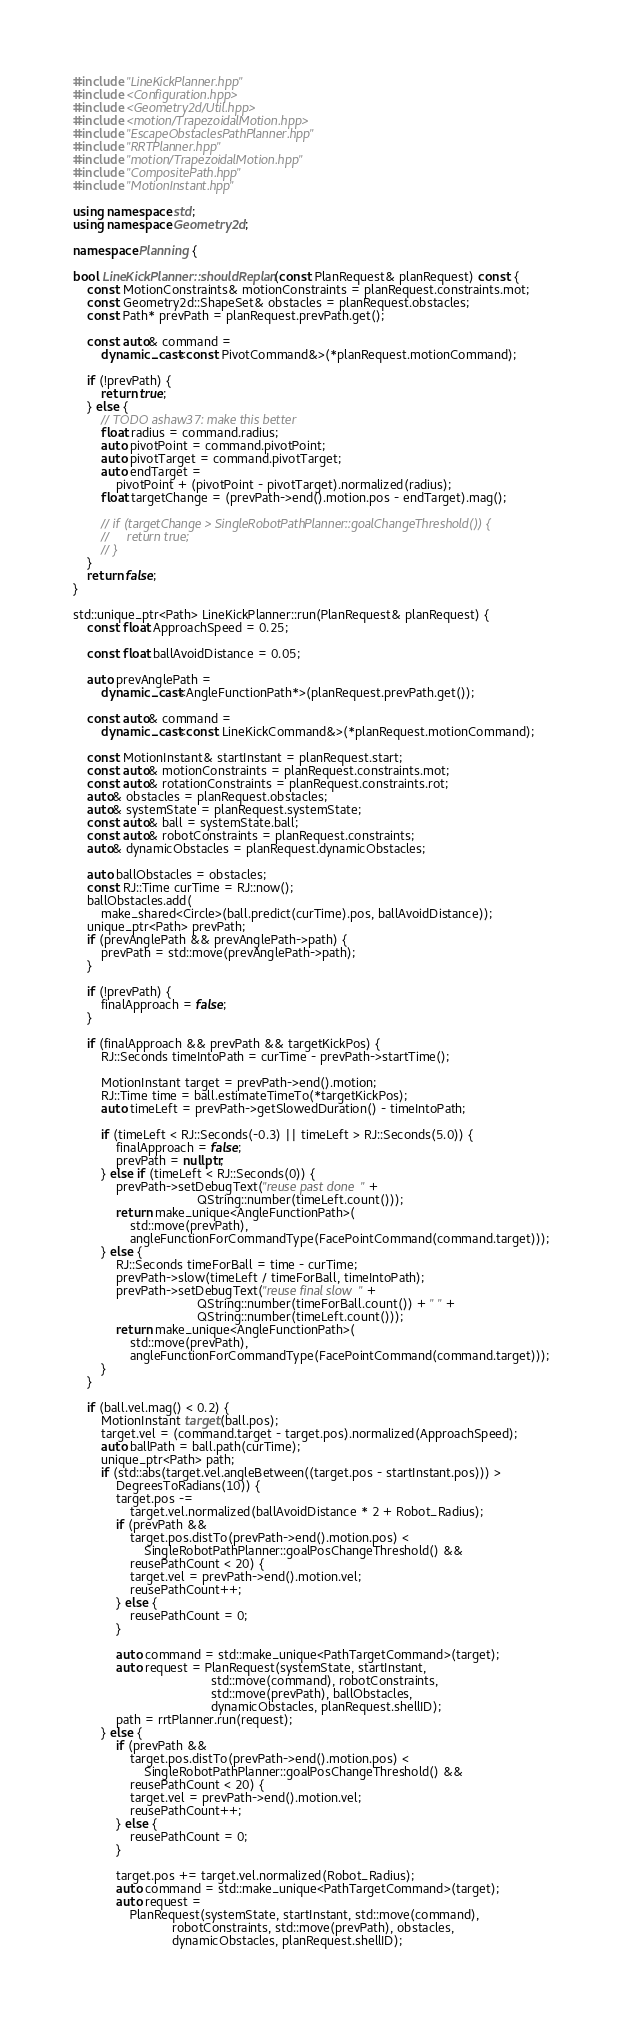<code> <loc_0><loc_0><loc_500><loc_500><_C++_>#include "LineKickPlanner.hpp"
#include <Configuration.hpp>
#include <Geometry2d/Util.hpp>
#include <motion/TrapezoidalMotion.hpp>
#include "EscapeObstaclesPathPlanner.hpp"
#include "RRTPlanner.hpp"
#include "motion/TrapezoidalMotion.hpp"
#include "CompositePath.hpp"
#include "MotionInstant.hpp"

using namespace std;
using namespace Geometry2d;

namespace Planning {

bool LineKickPlanner::shouldReplan(const PlanRequest& planRequest) const {
    const MotionConstraints& motionConstraints = planRequest.constraints.mot;
    const Geometry2d::ShapeSet& obstacles = planRequest.obstacles;
    const Path* prevPath = planRequest.prevPath.get();

    const auto& command =
        dynamic_cast<const PivotCommand&>(*planRequest.motionCommand);

    if (!prevPath) {
        return true;
    } else {
        // TODO ashaw37: make this better
        float radius = command.radius;
        auto pivotPoint = command.pivotPoint;
        auto pivotTarget = command.pivotTarget;
        auto endTarget =
            pivotPoint + (pivotPoint - pivotTarget).normalized(radius);
        float targetChange = (prevPath->end().motion.pos - endTarget).mag();

        // if (targetChange > SingleRobotPathPlanner::goalChangeThreshold()) {
        //     return true;
        // }
    }
    return false;
}

std::unique_ptr<Path> LineKickPlanner::run(PlanRequest& planRequest) {
    const float ApproachSpeed = 0.25;

    const float ballAvoidDistance = 0.05;

    auto prevAnglePath =
        dynamic_cast<AngleFunctionPath*>(planRequest.prevPath.get());

    const auto& command =
        dynamic_cast<const LineKickCommand&>(*planRequest.motionCommand);

    const MotionInstant& startInstant = planRequest.start;
    const auto& motionConstraints = planRequest.constraints.mot;
    const auto& rotationConstraints = planRequest.constraints.rot;
    auto& obstacles = planRequest.obstacles;
    auto& systemState = planRequest.systemState;
    const auto& ball = systemState.ball;
    const auto& robotConstraints = planRequest.constraints;
    auto& dynamicObstacles = planRequest.dynamicObstacles;

    auto ballObstacles = obstacles;
    const RJ::Time curTime = RJ::now();
    ballObstacles.add(
        make_shared<Circle>(ball.predict(curTime).pos, ballAvoidDistance));
    unique_ptr<Path> prevPath;
    if (prevAnglePath && prevAnglePath->path) {
        prevPath = std::move(prevAnglePath->path);
    }

    if (!prevPath) {
        finalApproach = false;
    }

    if (finalApproach && prevPath && targetKickPos) {
        RJ::Seconds timeIntoPath = curTime - prevPath->startTime();

        MotionInstant target = prevPath->end().motion;
        RJ::Time time = ball.estimateTimeTo(*targetKickPos);
        auto timeLeft = prevPath->getSlowedDuration() - timeIntoPath;

        if (timeLeft < RJ::Seconds(-0.3) || timeLeft > RJ::Seconds(5.0)) {
            finalApproach = false;
            prevPath = nullptr;
        } else if (timeLeft < RJ::Seconds(0)) {
            prevPath->setDebugText("reuse past done " +
                                   QString::number(timeLeft.count()));
            return make_unique<AngleFunctionPath>(
                std::move(prevPath),
                angleFunctionForCommandType(FacePointCommand(command.target)));
        } else {
            RJ::Seconds timeForBall = time - curTime;
            prevPath->slow(timeLeft / timeForBall, timeIntoPath);
            prevPath->setDebugText("reuse final slow " +
                                   QString::number(timeForBall.count()) + " " +
                                   QString::number(timeLeft.count()));
            return make_unique<AngleFunctionPath>(
                std::move(prevPath),
                angleFunctionForCommandType(FacePointCommand(command.target)));
        }
    }

    if (ball.vel.mag() < 0.2) {
        MotionInstant target(ball.pos);
        target.vel = (command.target - target.pos).normalized(ApproachSpeed);
        auto ballPath = ball.path(curTime);
        unique_ptr<Path> path;
        if (std::abs(target.vel.angleBetween((target.pos - startInstant.pos))) >
            DegreesToRadians(10)) {
            target.pos -=
                target.vel.normalized(ballAvoidDistance * 2 + Robot_Radius);
            if (prevPath &&
                target.pos.distTo(prevPath->end().motion.pos) <
                    SingleRobotPathPlanner::goalPosChangeThreshold() &&
                reusePathCount < 20) {
                target.vel = prevPath->end().motion.vel;
                reusePathCount++;
            } else {
                reusePathCount = 0;
            }

            auto command = std::make_unique<PathTargetCommand>(target);
            auto request = PlanRequest(systemState, startInstant,
                                       std::move(command), robotConstraints,
                                       std::move(prevPath), ballObstacles,
                                       dynamicObstacles, planRequest.shellID);
            path = rrtPlanner.run(request);
        } else {
            if (prevPath &&
                target.pos.distTo(prevPath->end().motion.pos) <
                    SingleRobotPathPlanner::goalPosChangeThreshold() &&
                reusePathCount < 20) {
                target.vel = prevPath->end().motion.vel;
                reusePathCount++;
            } else {
                reusePathCount = 0;
            }

            target.pos += target.vel.normalized(Robot_Radius);
            auto command = std::make_unique<PathTargetCommand>(target);
            auto request =
                PlanRequest(systemState, startInstant, std::move(command),
                            robotConstraints, std::move(prevPath), obstacles,
                            dynamicObstacles, planRequest.shellID);
</code> 